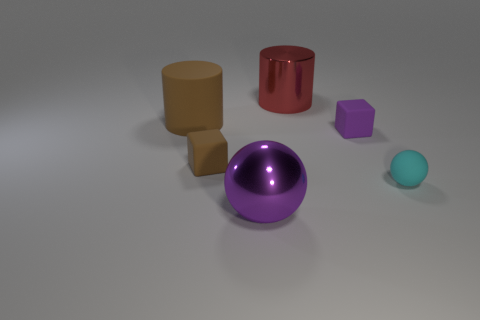What shape is the purple object in front of the small cube that is left of the tiny purple matte thing?
Provide a short and direct response. Sphere. There is a big cylinder in front of the large red shiny thing; is its color the same as the rubber ball?
Provide a short and direct response. No. What color is the object that is both behind the purple cube and right of the tiny brown object?
Your response must be concise. Red. Are there any big brown things that have the same material as the small purple thing?
Provide a short and direct response. Yes. How big is the purple metal thing?
Make the answer very short. Large. What is the size of the matte block that is on the right side of the metal object that is behind the purple metallic sphere?
Ensure brevity in your answer.  Small. There is another large thing that is the same shape as the red object; what is it made of?
Provide a short and direct response. Rubber. What number of small purple metal cubes are there?
Your answer should be very brief. 0. There is a shiny thing that is behind the big thing in front of the rubber object on the left side of the small brown rubber cube; what is its color?
Your response must be concise. Red. Is the number of cubes less than the number of large purple balls?
Your answer should be very brief. No. 